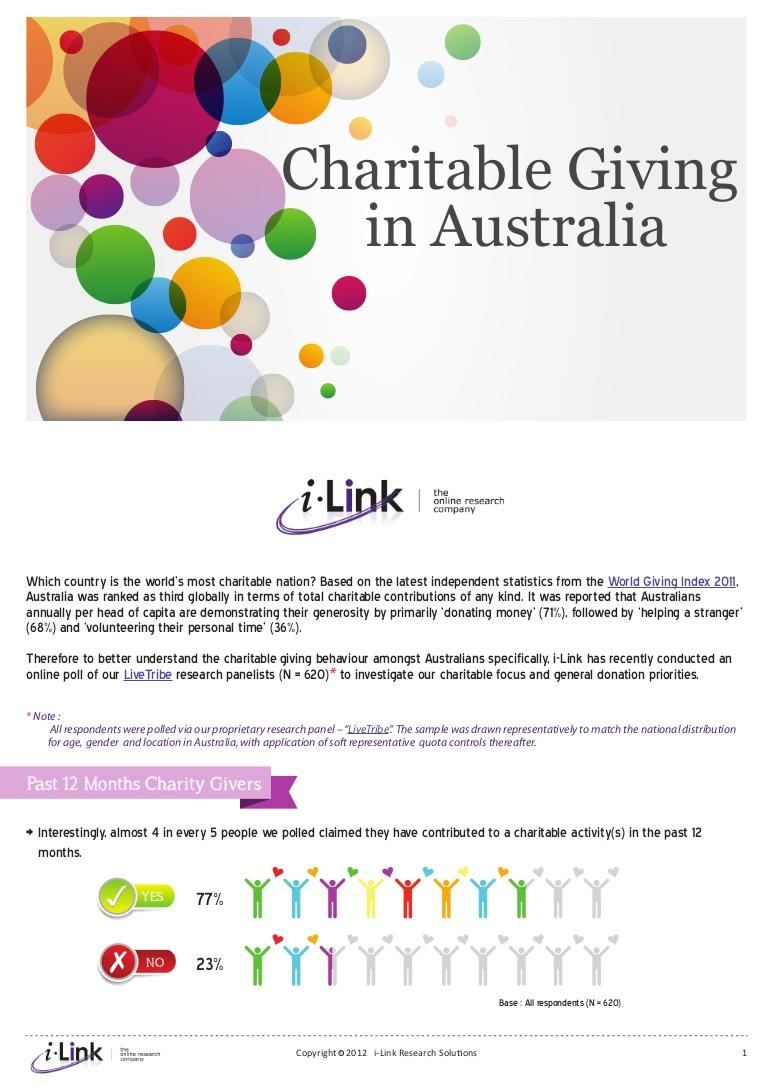List a handful of essential elements in this visual. In the past year, approximately 23% of people have not contributed to charity. According to a recent survey, 77% of people have contributed to charity in the last year. 